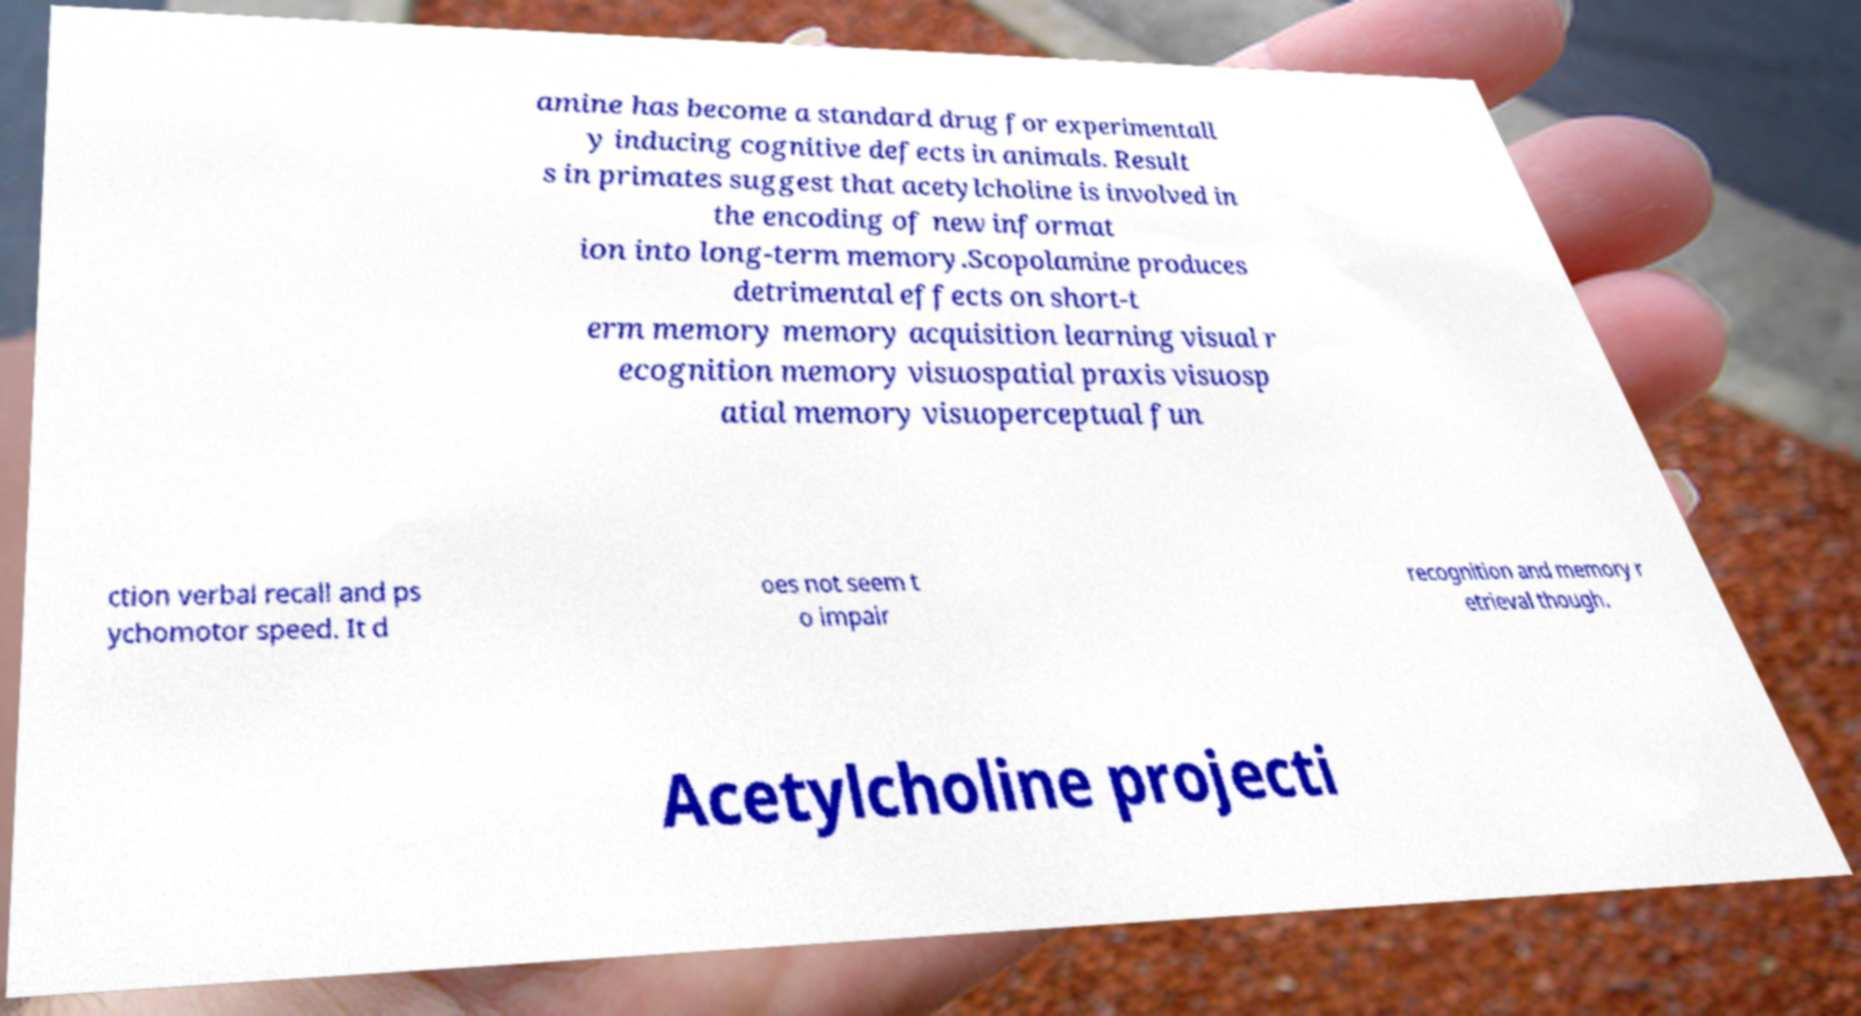Can you read and provide the text displayed in the image?This photo seems to have some interesting text. Can you extract and type it out for me? amine has become a standard drug for experimentall y inducing cognitive defects in animals. Result s in primates suggest that acetylcholine is involved in the encoding of new informat ion into long-term memory.Scopolamine produces detrimental effects on short-t erm memory memory acquisition learning visual r ecognition memory visuospatial praxis visuosp atial memory visuoperceptual fun ction verbal recall and ps ychomotor speed. It d oes not seem t o impair recognition and memory r etrieval though. Acetylcholine projecti 